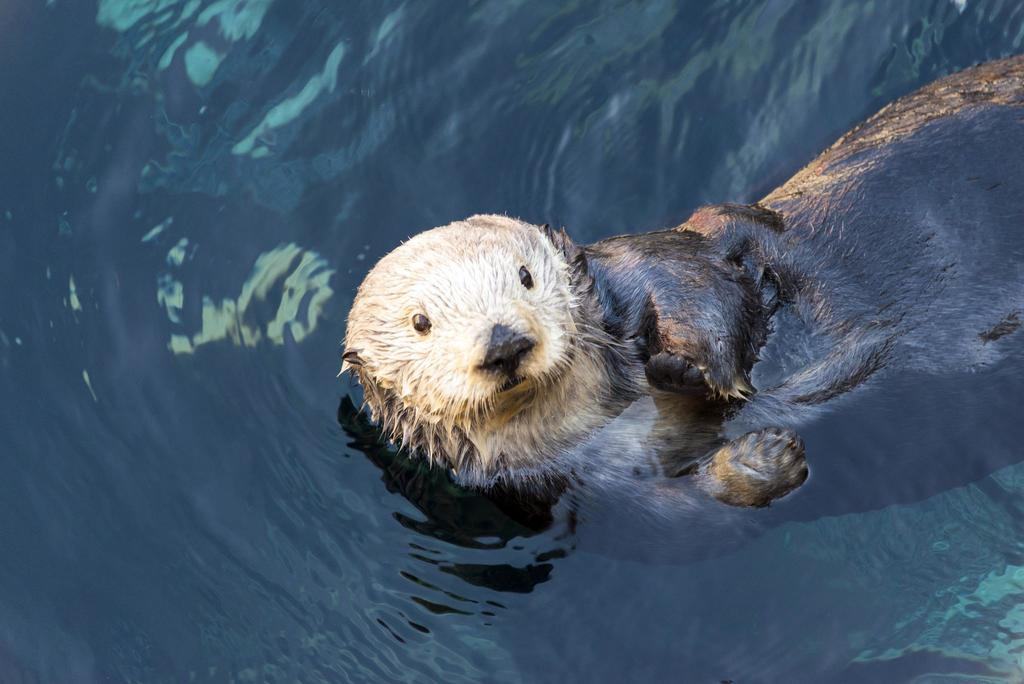What type of animal is in the picture? There is a sea otter in the picture. What is the primary setting of the picture? There is water visible at the bottom of the picture. What type of business is the sea otter running in the picture? There is no indication of a business in the picture; it simply features a sea otter in the water. 